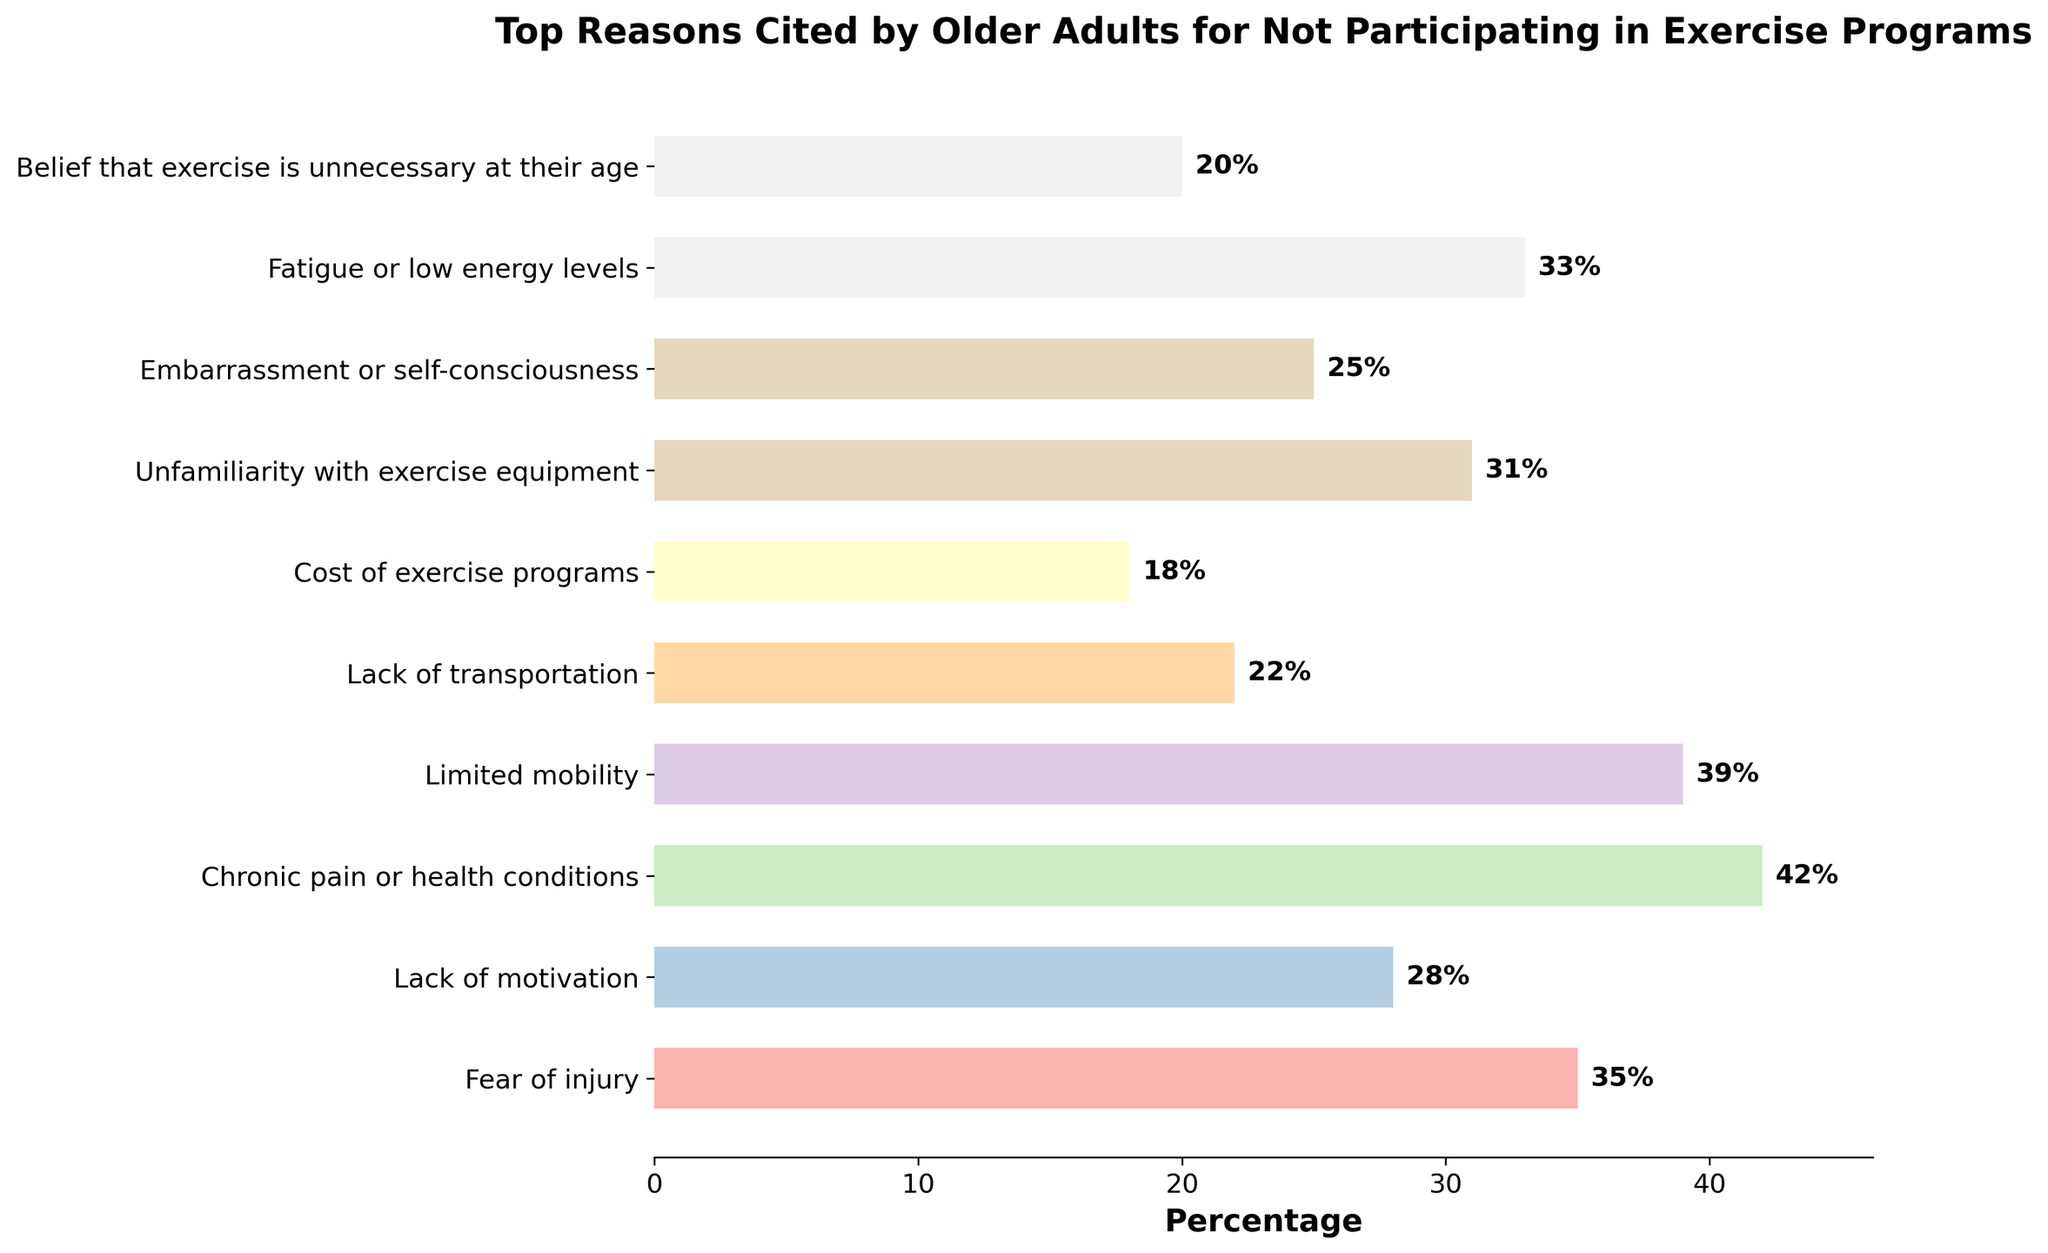Which reason is cited by the highest percentage of older adults for not participating in exercise programs? The bar representing "Chronic pain or health conditions" is the highest among all other bars, indicating it has the largest percentage.
Answer: Chronic pain or health conditions Which reason has a lower percentage, fear of injury or lack of motivation? Comparing the bar lengths for "Fear of injury" and "Lack of motivation," the bar for "Lack of motivation" is shorter.
Answer: Lack of motivation What is the combined percentage of older adults citing fear of injury and lack of transportation as reasons? The percentage for "Fear of injury" is 35%, and for "Lack of transportation" is 22%. Adding these gives 35% + 22% = 57%.
Answer: 57% Which reason is cited by more people: unfamiliarity with exercise equipment or fatigue or low energy levels? Comparing the bar lengths for "Unfamiliarity with exercise equipment" and "Fatigue or low energy levels," the bar for "Fatigue or low energy levels" is slightly higher.
Answer: Fatigue or low energy levels What is the difference in percentage between those citing limited mobility and those citing belief that exercise is unnecessary at their age? The percentage for "Limited mobility" is 39%, and for "Belief that exercise is unnecessary at their age" is 20%. The difference is 39% - 20% = 19%.
Answer: 19% Which reason, embarrassment or self-consciousness, or cost of exercise programs, has a higher percentage? Comparing the bar lengths for "Embarrassment or self-consciousness" and "Cost of exercise programs," the bar for "Embarrassment or self-consciousness" is higher.
Answer: Embarrassment or self-consciousness Identify the reasons cited by more than 30% of the older adults. The bars for "Fear of injury," "Limited mobility," "Unfamiliarity with exercise equipment," chronic pain," and fatigue all exceed 30%.
Answer: Fear of injury, Limited mobility, Unfamiliarity with exercise equipment, Chronic pain, Fatigue What is the average percentage of the cited reasons based on the available data? Summing all percentages: 35% + 28% + 42% + 39% + 22% + 18% + 31% + 25% + 33% + 20% = 293%. There are 10 reasons, so the average is 293% / 10 = 29.3%.
Answer: 29.3% How does the percentage of those citing chronic pain compare to the average percentage of all reasons? Chronic pain has a percentage of 42%. The average percentage of all reasons is 29.3%. 42% is higher than 29.3%.
Answer: Higher 